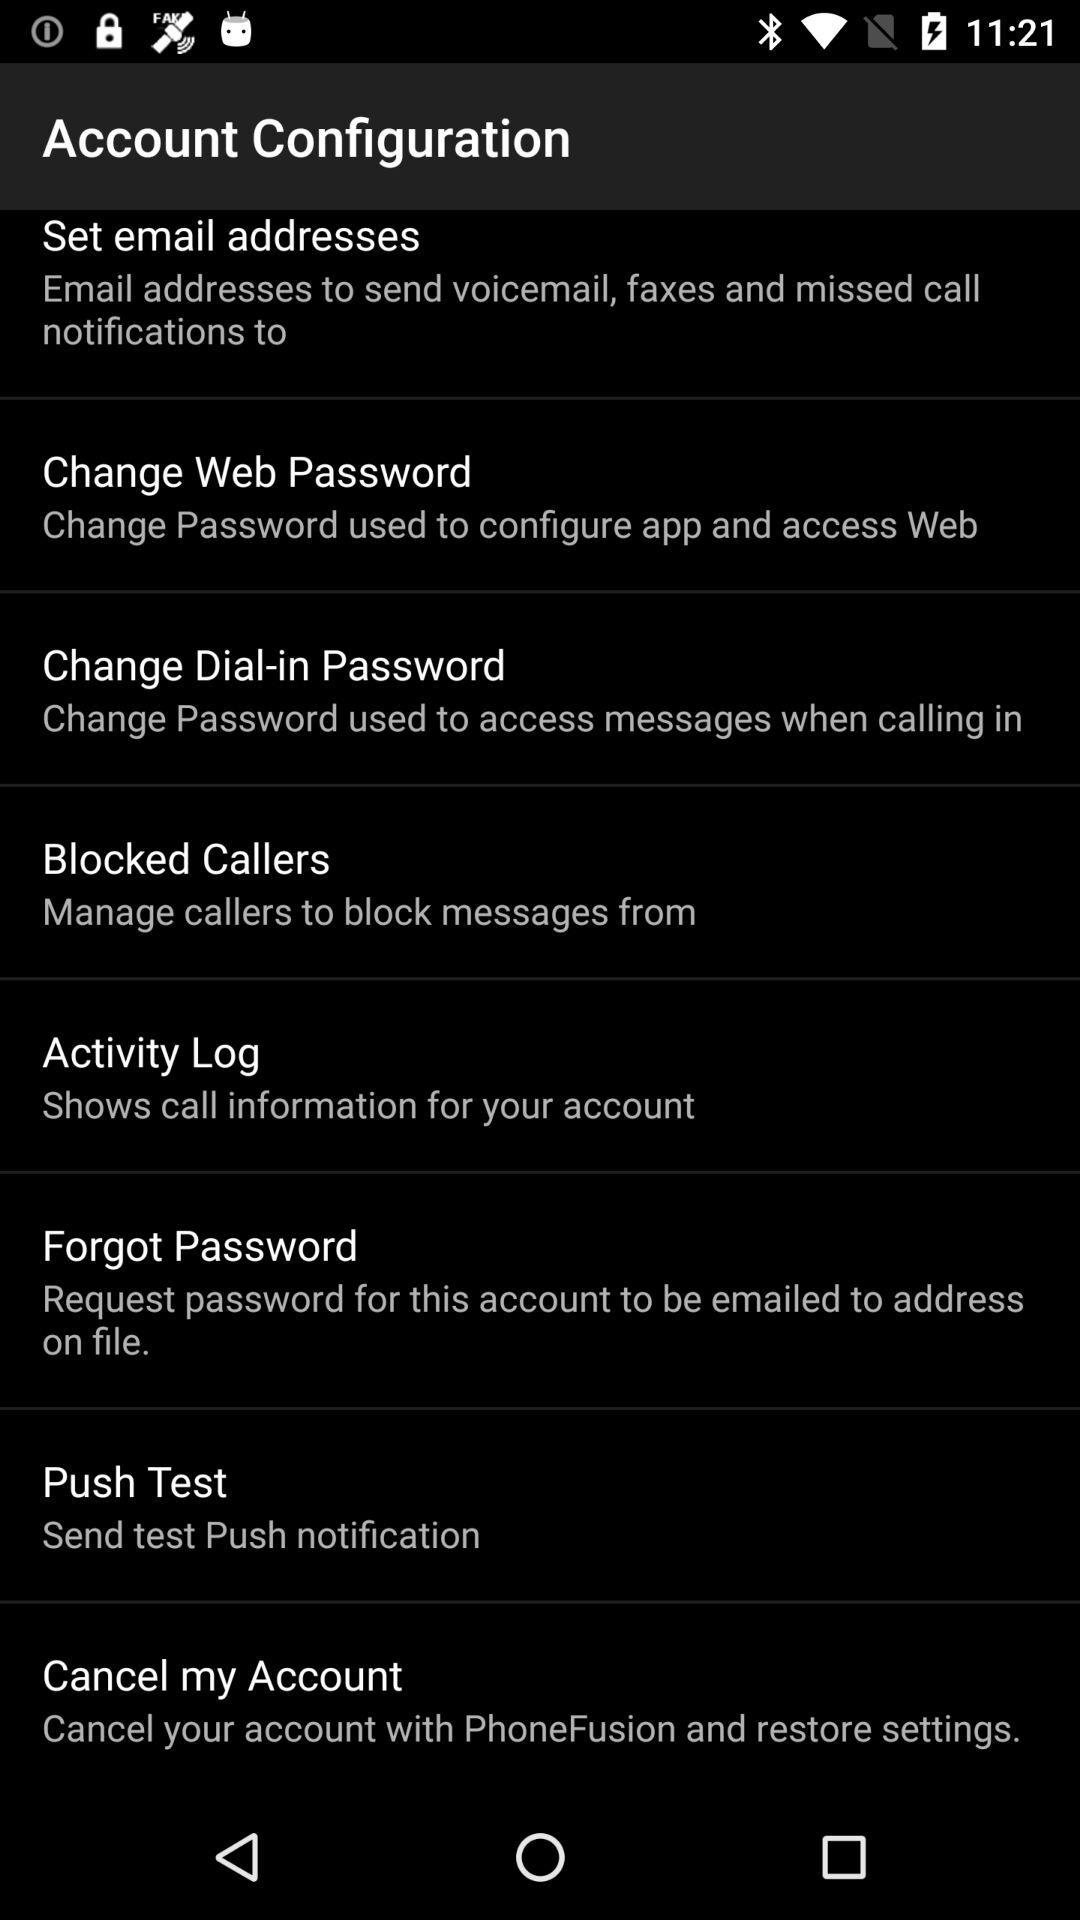What is the description of "Forgot Password"? The description is "Request password for this account to be emailed to address on file". 